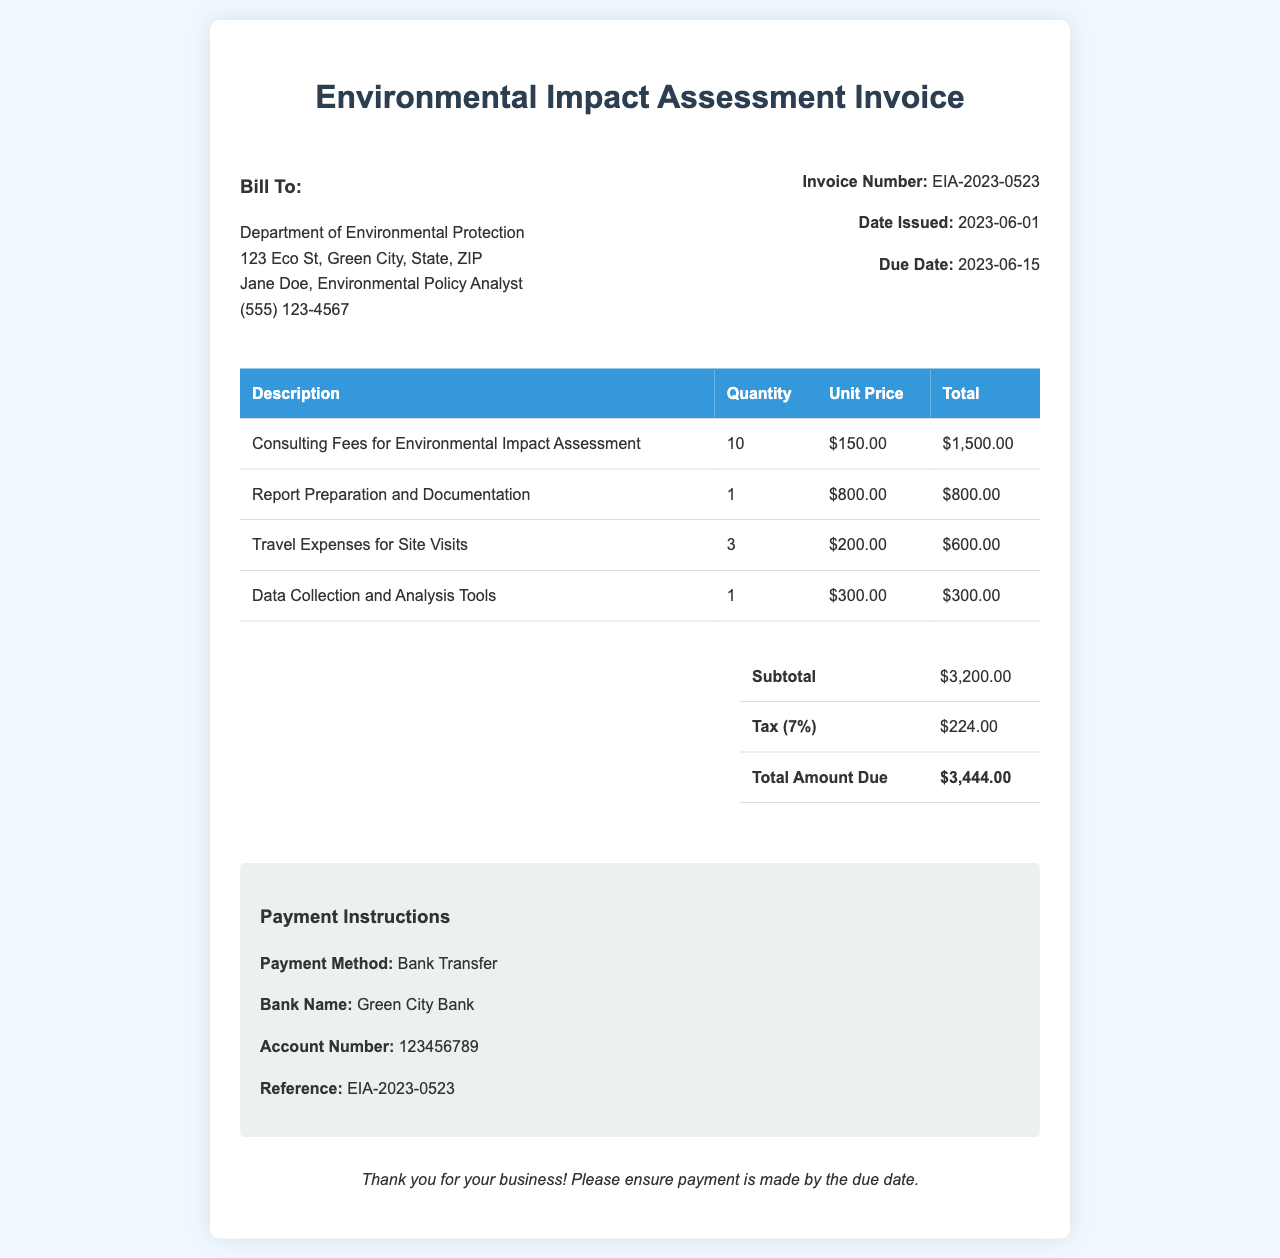What is the invoice number? The invoice number is listed in the document under invoice information.
Answer: EIA-2023-0523 What is the date issued? The date issued is provided in the invoice details section.
Answer: 2023-06-01 What is the total amount due? The total amount due is listed in the summary section of the invoice.
Answer: $3,444.00 How much were the consulting fees? The consulting fees are specified in the table under the description.
Answer: $1,500.00 Who is the contact person for the bill? The contact person's name is provided in the "Bill To" section of the document.
Answer: Jane Doe What is the tax percentage applied? The tax percentage can be calculated from the tax entry provided in the summary.
Answer: 7% How many travel expenses were charged? The quantity of travel expenses is listed in the table within the invoice.
Answer: 3 What is the payment method? The payment method is mentioned in the payment instructions section.
Answer: Bank Transfer What is the due date? The due date is indicated in the invoice details part of the document.
Answer: 2023-06-15 